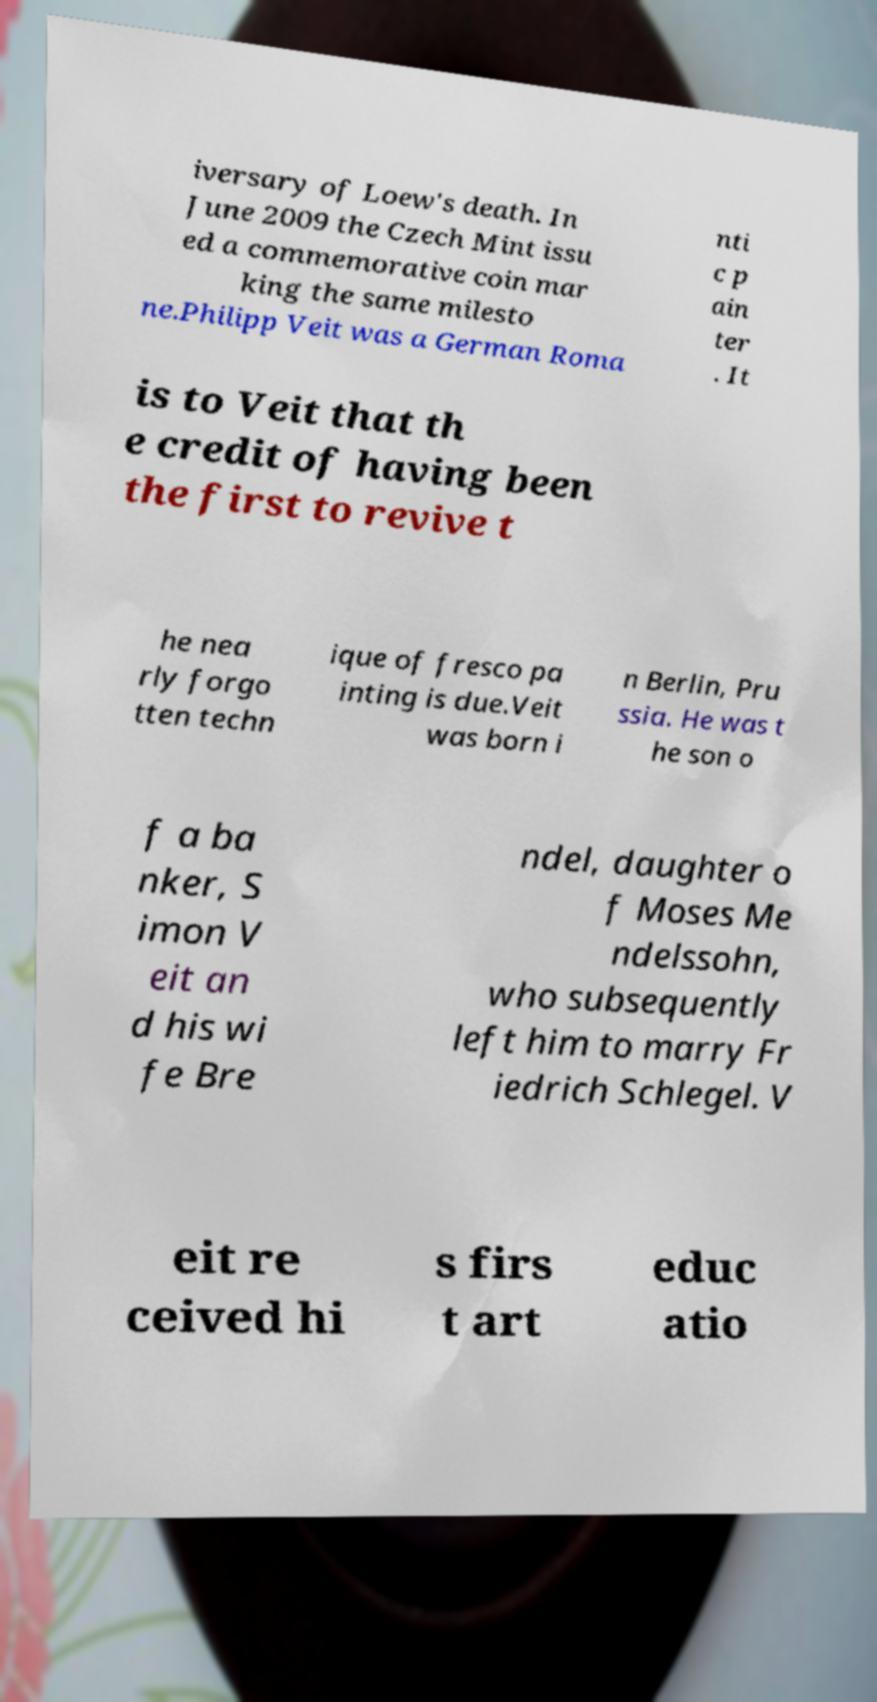I need the written content from this picture converted into text. Can you do that? iversary of Loew's death. In June 2009 the Czech Mint issu ed a commemorative coin mar king the same milesto ne.Philipp Veit was a German Roma nti c p ain ter . It is to Veit that th e credit of having been the first to revive t he nea rly forgo tten techn ique of fresco pa inting is due.Veit was born i n Berlin, Pru ssia. He was t he son o f a ba nker, S imon V eit an d his wi fe Bre ndel, daughter o f Moses Me ndelssohn, who subsequently left him to marry Fr iedrich Schlegel. V eit re ceived hi s firs t art educ atio 